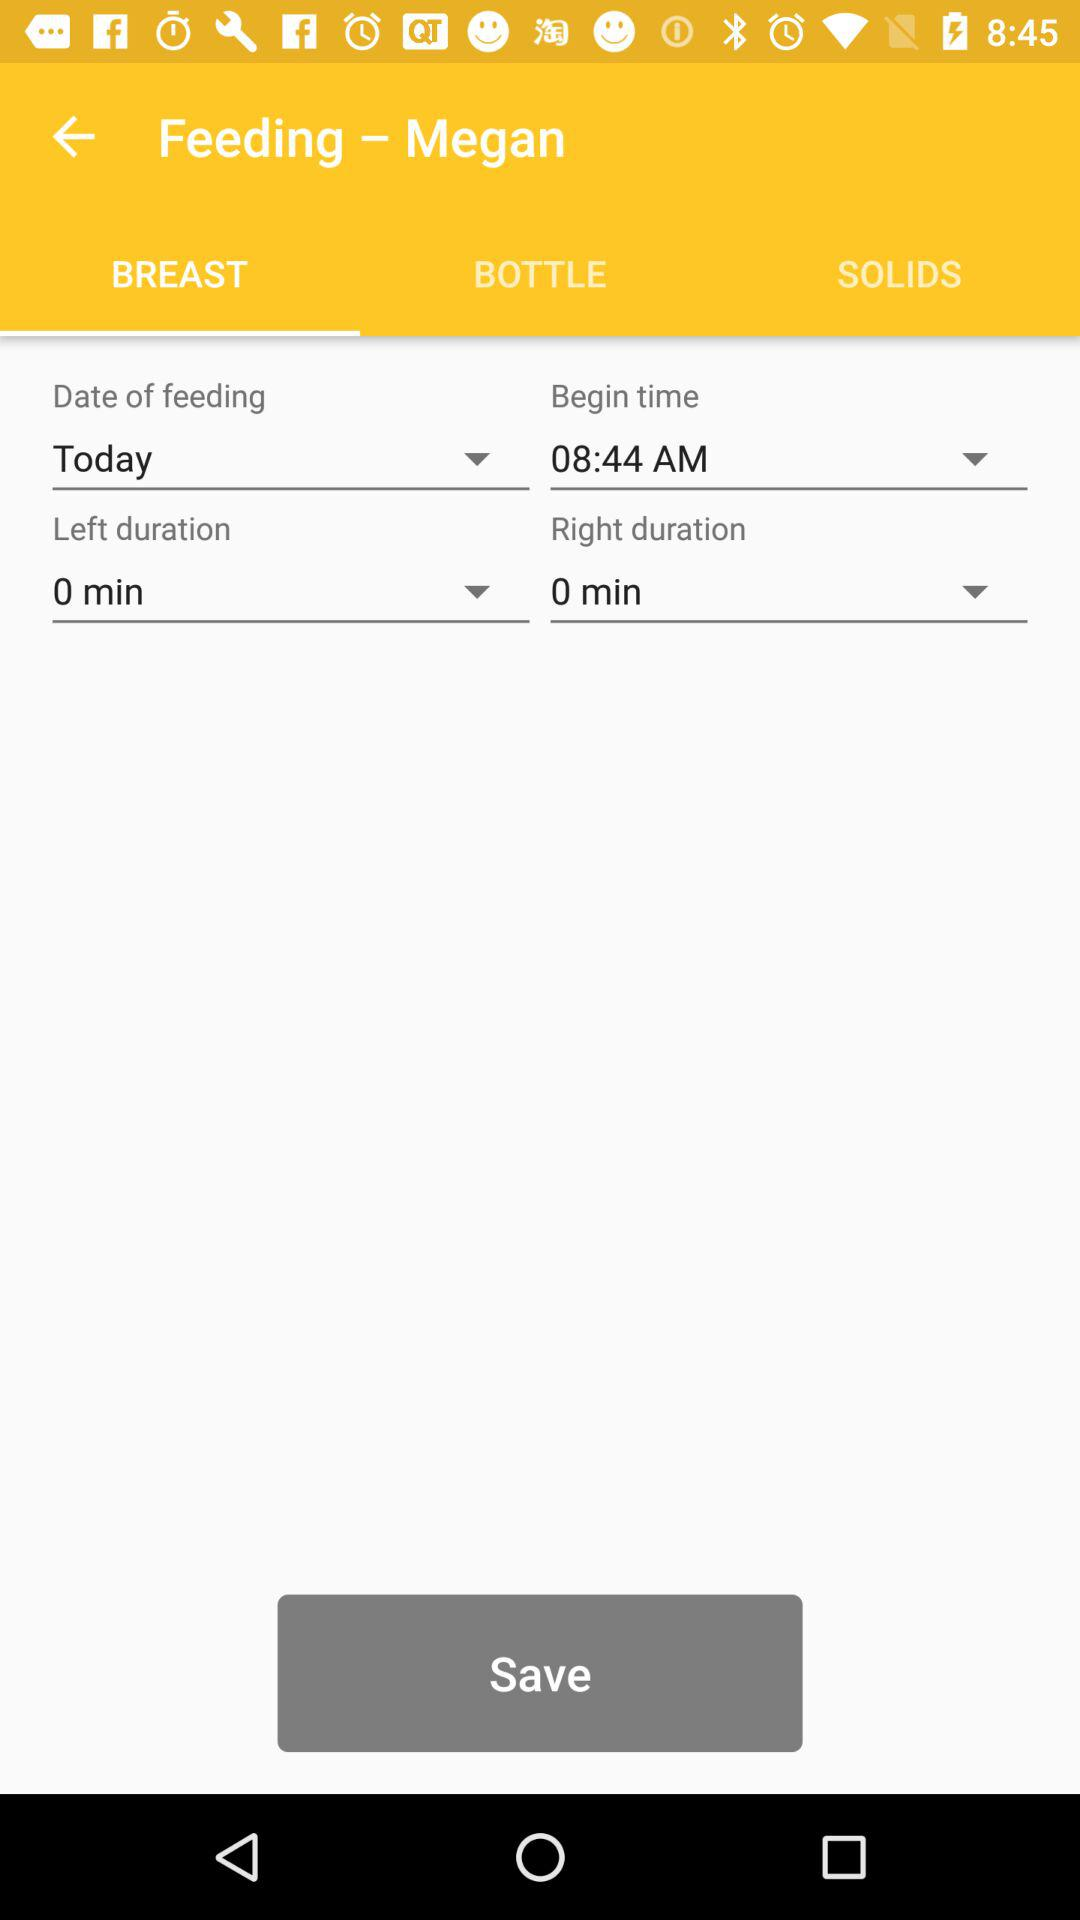What is the right duration? The right duration is 0 minutes. 